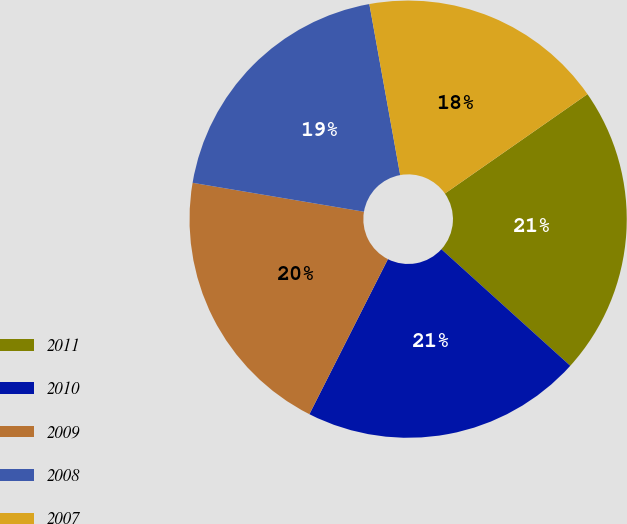Convert chart to OTSL. <chart><loc_0><loc_0><loc_500><loc_500><pie_chart><fcel>2011<fcel>2010<fcel>2009<fcel>2008<fcel>2007<nl><fcel>21.39%<fcel>20.76%<fcel>20.2%<fcel>19.5%<fcel>18.15%<nl></chart> 